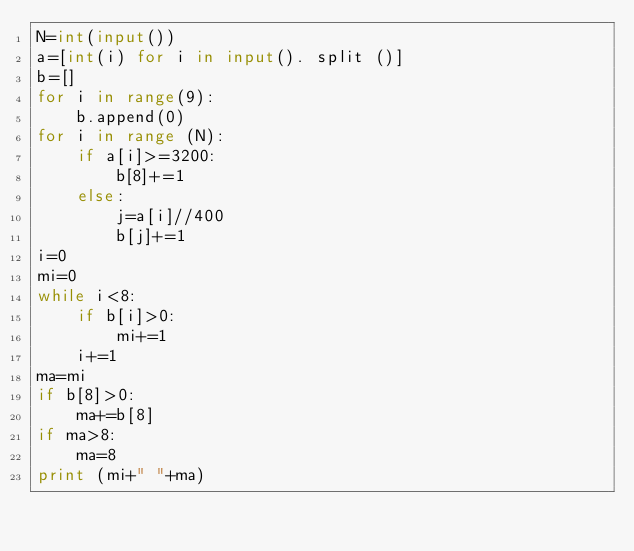<code> <loc_0><loc_0><loc_500><loc_500><_Python_>N=int(input())
a=[int(i) for i in input(). split ()]
b=[]
for i in range(9):
    b.append(0)
for i in range (N):
    if a[i]>=3200:
        b[8]+=1
    else:
        j=a[i]//400
        b[j]+=1
i=0
mi=0
while i<8:
    if b[i]>0:
        mi+=1
    i+=1
ma=mi
if b[8]>0:
    ma+=b[8]
if ma>8:
    ma=8
print (mi+" "+ma)</code> 